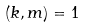<formula> <loc_0><loc_0><loc_500><loc_500>( k , m ) = 1</formula> 